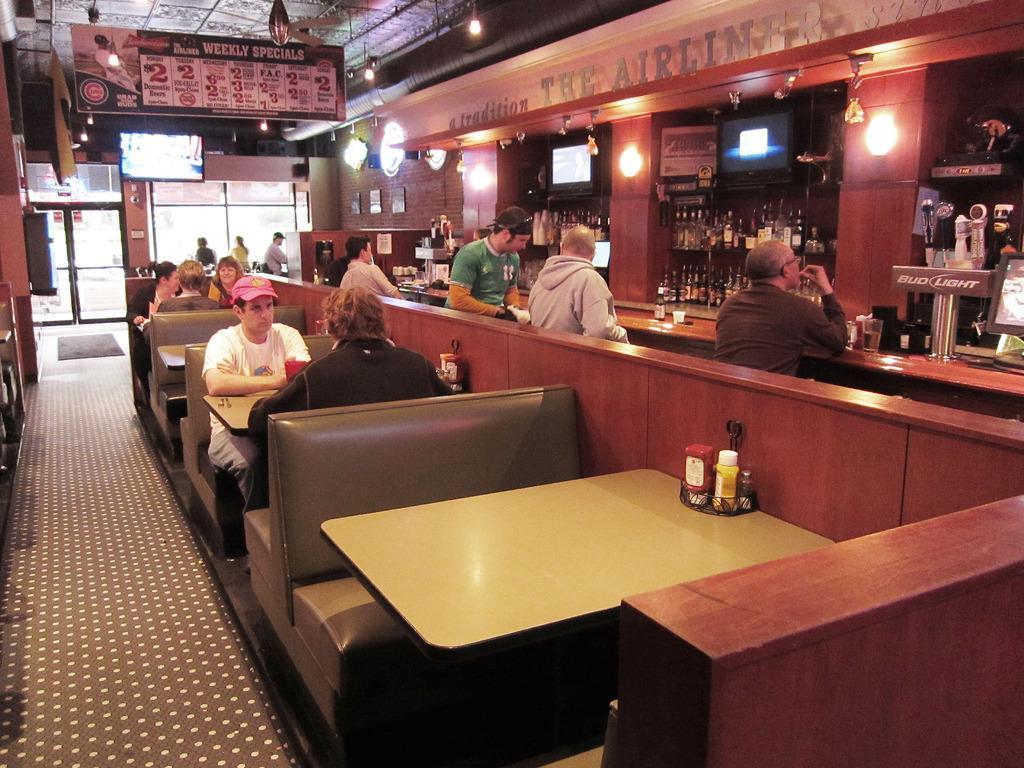How would you summarize this image in a sentence or two? In this picture i could see many persons sitting near by the counter top of the bar to the right side of the picture. There are bottles on the shelves and in the middle of the picture there are dining tables and chairs and there is a dotted carpet on the floor and in the back ground there is a glass door and window. 